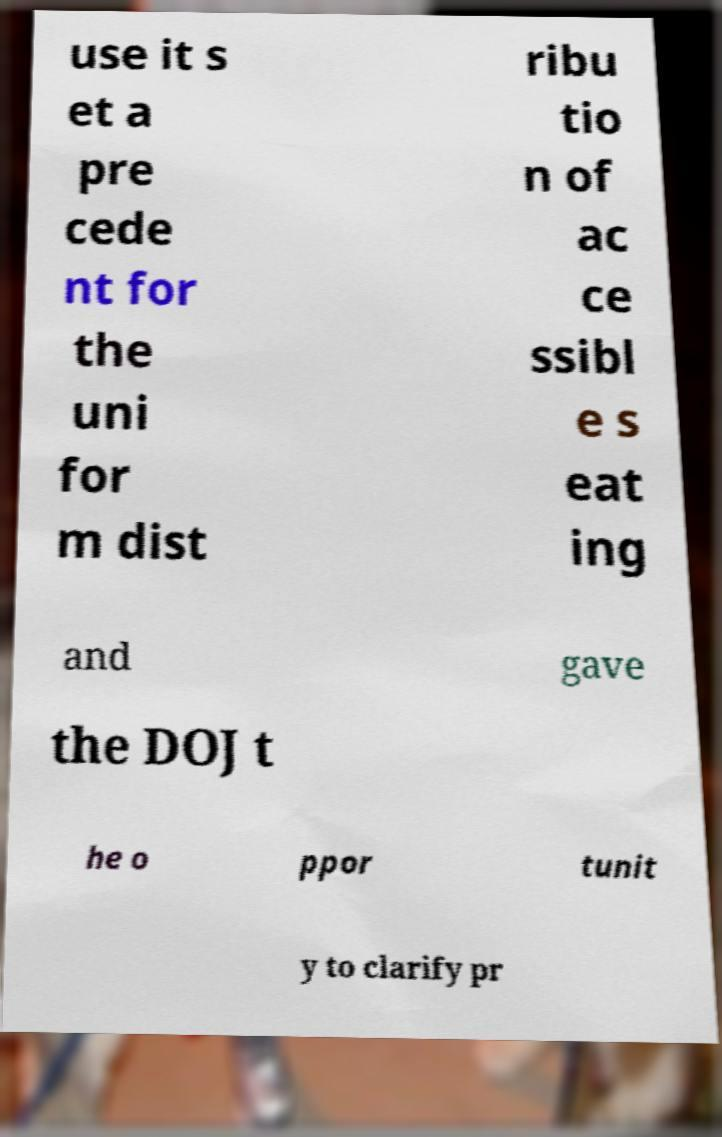There's text embedded in this image that I need extracted. Can you transcribe it verbatim? use it s et a pre cede nt for the uni for m dist ribu tio n of ac ce ssibl e s eat ing and gave the DOJ t he o ppor tunit y to clarify pr 